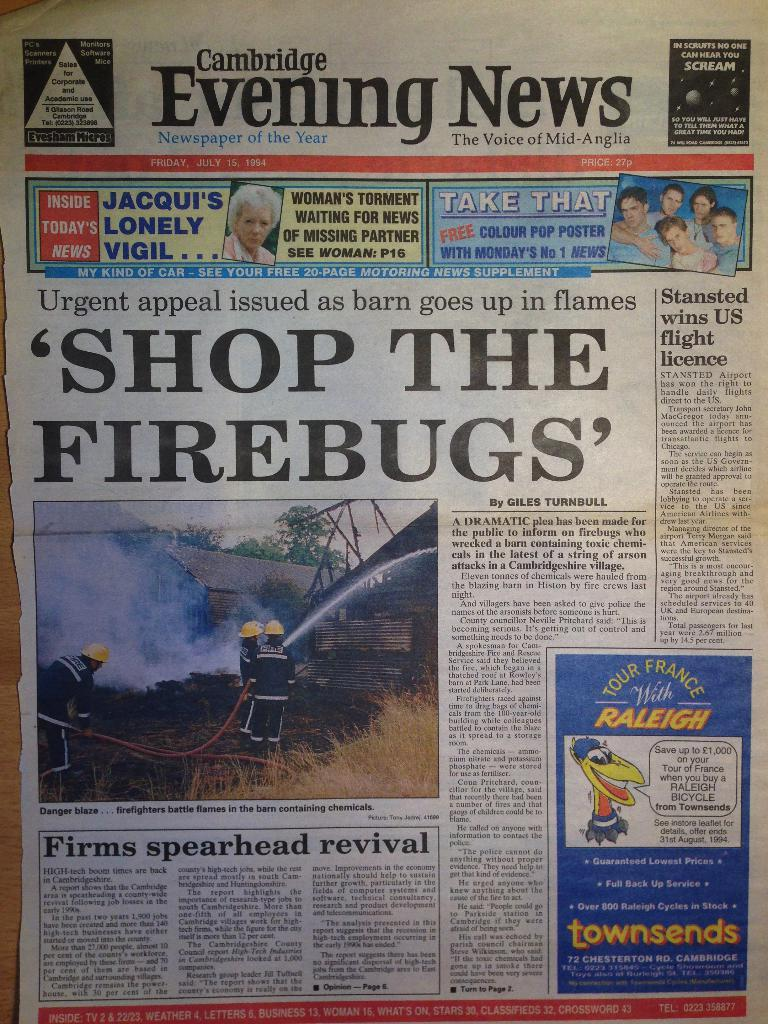What type of printed material is present in the image? The image contains a newspaper. How is the newspaper displayed in the image? The newspaper is displayed with its front page. What can be found within the newspaper? There are advertisements and headlines mentioned in the newspaper. How many balloons are floating above the newspaper in the image? There are no balloons present in the image. What type of birds can be seen interacting with the newspaper in the image? There are no birds interacting with the newspaper in the image. 